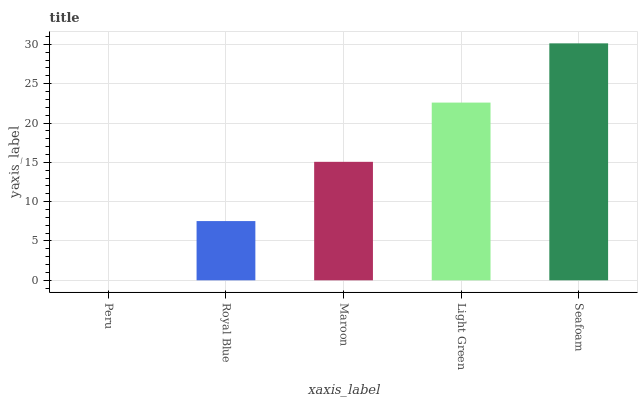Is Peru the minimum?
Answer yes or no. Yes. Is Seafoam the maximum?
Answer yes or no. Yes. Is Royal Blue the minimum?
Answer yes or no. No. Is Royal Blue the maximum?
Answer yes or no. No. Is Royal Blue greater than Peru?
Answer yes or no. Yes. Is Peru less than Royal Blue?
Answer yes or no. Yes. Is Peru greater than Royal Blue?
Answer yes or no. No. Is Royal Blue less than Peru?
Answer yes or no. No. Is Maroon the high median?
Answer yes or no. Yes. Is Maroon the low median?
Answer yes or no. Yes. Is Light Green the high median?
Answer yes or no. No. Is Seafoam the low median?
Answer yes or no. No. 